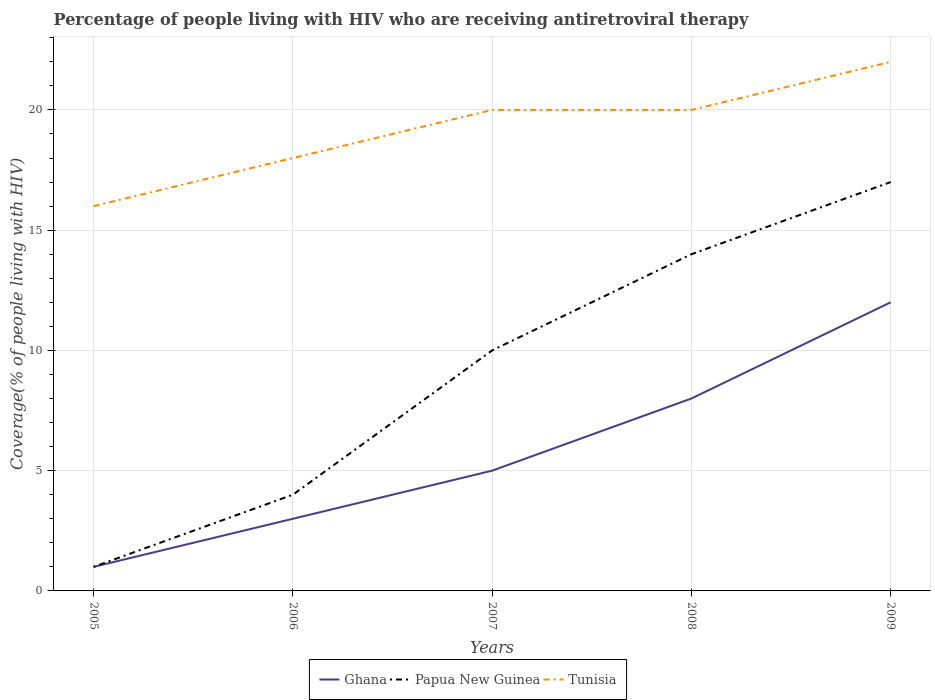How many different coloured lines are there?
Provide a short and direct response. 3. Does the line corresponding to Tunisia intersect with the line corresponding to Ghana?
Ensure brevity in your answer.  No. Is the number of lines equal to the number of legend labels?
Your answer should be compact. Yes. Across all years, what is the maximum percentage of the HIV infected people who are receiving antiretroviral therapy in Ghana?
Offer a terse response. 1. In which year was the percentage of the HIV infected people who are receiving antiretroviral therapy in Tunisia maximum?
Make the answer very short. 2005. What is the total percentage of the HIV infected people who are receiving antiretroviral therapy in Papua New Guinea in the graph?
Your response must be concise. -3. Are the values on the major ticks of Y-axis written in scientific E-notation?
Your answer should be very brief. No. Does the graph contain any zero values?
Give a very brief answer. No. Does the graph contain grids?
Provide a short and direct response. Yes. Where does the legend appear in the graph?
Offer a terse response. Bottom center. How many legend labels are there?
Provide a succinct answer. 3. How are the legend labels stacked?
Provide a succinct answer. Horizontal. What is the title of the graph?
Provide a short and direct response. Percentage of people living with HIV who are receiving antiretroviral therapy. What is the label or title of the X-axis?
Offer a very short reply. Years. What is the label or title of the Y-axis?
Offer a terse response. Coverage(% of people living with HIV). What is the Coverage(% of people living with HIV) of Papua New Guinea in 2006?
Give a very brief answer. 4. What is the Coverage(% of people living with HIV) in Papua New Guinea in 2008?
Your answer should be very brief. 14. What is the Coverage(% of people living with HIV) of Ghana in 2009?
Offer a terse response. 12. What is the Coverage(% of people living with HIV) of Tunisia in 2009?
Keep it short and to the point. 22. Across all years, what is the maximum Coverage(% of people living with HIV) in Ghana?
Keep it short and to the point. 12. Across all years, what is the maximum Coverage(% of people living with HIV) of Tunisia?
Keep it short and to the point. 22. Across all years, what is the minimum Coverage(% of people living with HIV) in Ghana?
Give a very brief answer. 1. What is the total Coverage(% of people living with HIV) of Tunisia in the graph?
Offer a very short reply. 96. What is the difference between the Coverage(% of people living with HIV) in Papua New Guinea in 2005 and that in 2006?
Provide a succinct answer. -3. What is the difference between the Coverage(% of people living with HIV) in Ghana in 2005 and that in 2007?
Make the answer very short. -4. What is the difference between the Coverage(% of people living with HIV) of Papua New Guinea in 2005 and that in 2007?
Keep it short and to the point. -9. What is the difference between the Coverage(% of people living with HIV) in Tunisia in 2005 and that in 2007?
Ensure brevity in your answer.  -4. What is the difference between the Coverage(% of people living with HIV) in Papua New Guinea in 2005 and that in 2009?
Keep it short and to the point. -16. What is the difference between the Coverage(% of people living with HIV) of Tunisia in 2005 and that in 2009?
Provide a succinct answer. -6. What is the difference between the Coverage(% of people living with HIV) in Ghana in 2006 and that in 2007?
Provide a short and direct response. -2. What is the difference between the Coverage(% of people living with HIV) of Papua New Guinea in 2006 and that in 2007?
Your response must be concise. -6. What is the difference between the Coverage(% of people living with HIV) in Tunisia in 2006 and that in 2009?
Your answer should be very brief. -4. What is the difference between the Coverage(% of people living with HIV) of Tunisia in 2007 and that in 2008?
Offer a terse response. 0. What is the difference between the Coverage(% of people living with HIV) of Papua New Guinea in 2007 and that in 2009?
Offer a terse response. -7. What is the difference between the Coverage(% of people living with HIV) in Ghana in 2008 and that in 2009?
Your response must be concise. -4. What is the difference between the Coverage(% of people living with HIV) of Ghana in 2005 and the Coverage(% of people living with HIV) of Papua New Guinea in 2006?
Your answer should be compact. -3. What is the difference between the Coverage(% of people living with HIV) of Ghana in 2005 and the Coverage(% of people living with HIV) of Tunisia in 2006?
Ensure brevity in your answer.  -17. What is the difference between the Coverage(% of people living with HIV) in Ghana in 2005 and the Coverage(% of people living with HIV) in Papua New Guinea in 2007?
Your response must be concise. -9. What is the difference between the Coverage(% of people living with HIV) in Ghana in 2005 and the Coverage(% of people living with HIV) in Tunisia in 2007?
Give a very brief answer. -19. What is the difference between the Coverage(% of people living with HIV) of Ghana in 2005 and the Coverage(% of people living with HIV) of Papua New Guinea in 2008?
Ensure brevity in your answer.  -13. What is the difference between the Coverage(% of people living with HIV) of Ghana in 2005 and the Coverage(% of people living with HIV) of Tunisia in 2008?
Give a very brief answer. -19. What is the difference between the Coverage(% of people living with HIV) in Papua New Guinea in 2005 and the Coverage(% of people living with HIV) in Tunisia in 2008?
Ensure brevity in your answer.  -19. What is the difference between the Coverage(% of people living with HIV) in Ghana in 2006 and the Coverage(% of people living with HIV) in Papua New Guinea in 2007?
Your response must be concise. -7. What is the difference between the Coverage(% of people living with HIV) in Papua New Guinea in 2006 and the Coverage(% of people living with HIV) in Tunisia in 2007?
Make the answer very short. -16. What is the difference between the Coverage(% of people living with HIV) in Papua New Guinea in 2006 and the Coverage(% of people living with HIV) in Tunisia in 2008?
Give a very brief answer. -16. What is the difference between the Coverage(% of people living with HIV) in Ghana in 2006 and the Coverage(% of people living with HIV) in Tunisia in 2009?
Provide a succinct answer. -19. What is the difference between the Coverage(% of people living with HIV) in Ghana in 2007 and the Coverage(% of people living with HIV) in Papua New Guinea in 2008?
Keep it short and to the point. -9. What is the difference between the Coverage(% of people living with HIV) of Papua New Guinea in 2007 and the Coverage(% of people living with HIV) of Tunisia in 2008?
Provide a succinct answer. -10. What is the difference between the Coverage(% of people living with HIV) in Ghana in 2007 and the Coverage(% of people living with HIV) in Papua New Guinea in 2009?
Offer a very short reply. -12. What is the difference between the Coverage(% of people living with HIV) in Ghana in 2008 and the Coverage(% of people living with HIV) in Papua New Guinea in 2009?
Provide a succinct answer. -9. What is the average Coverage(% of people living with HIV) of Ghana per year?
Ensure brevity in your answer.  5.8. In the year 2005, what is the difference between the Coverage(% of people living with HIV) in Ghana and Coverage(% of people living with HIV) in Papua New Guinea?
Offer a terse response. 0. In the year 2005, what is the difference between the Coverage(% of people living with HIV) of Papua New Guinea and Coverage(% of people living with HIV) of Tunisia?
Ensure brevity in your answer.  -15. In the year 2006, what is the difference between the Coverage(% of people living with HIV) of Ghana and Coverage(% of people living with HIV) of Tunisia?
Offer a terse response. -15. In the year 2006, what is the difference between the Coverage(% of people living with HIV) of Papua New Guinea and Coverage(% of people living with HIV) of Tunisia?
Your response must be concise. -14. In the year 2007, what is the difference between the Coverage(% of people living with HIV) of Papua New Guinea and Coverage(% of people living with HIV) of Tunisia?
Provide a succinct answer. -10. In the year 2008, what is the difference between the Coverage(% of people living with HIV) of Ghana and Coverage(% of people living with HIV) of Papua New Guinea?
Make the answer very short. -6. In the year 2008, what is the difference between the Coverage(% of people living with HIV) in Ghana and Coverage(% of people living with HIV) in Tunisia?
Your answer should be compact. -12. In the year 2008, what is the difference between the Coverage(% of people living with HIV) in Papua New Guinea and Coverage(% of people living with HIV) in Tunisia?
Provide a succinct answer. -6. In the year 2009, what is the difference between the Coverage(% of people living with HIV) of Ghana and Coverage(% of people living with HIV) of Tunisia?
Keep it short and to the point. -10. What is the ratio of the Coverage(% of people living with HIV) in Papua New Guinea in 2005 to that in 2006?
Make the answer very short. 0.25. What is the ratio of the Coverage(% of people living with HIV) of Tunisia in 2005 to that in 2006?
Provide a succinct answer. 0.89. What is the ratio of the Coverage(% of people living with HIV) in Papua New Guinea in 2005 to that in 2007?
Ensure brevity in your answer.  0.1. What is the ratio of the Coverage(% of people living with HIV) of Tunisia in 2005 to that in 2007?
Your response must be concise. 0.8. What is the ratio of the Coverage(% of people living with HIV) of Ghana in 2005 to that in 2008?
Your response must be concise. 0.12. What is the ratio of the Coverage(% of people living with HIV) in Papua New Guinea in 2005 to that in 2008?
Offer a terse response. 0.07. What is the ratio of the Coverage(% of people living with HIV) in Ghana in 2005 to that in 2009?
Give a very brief answer. 0.08. What is the ratio of the Coverage(% of people living with HIV) of Papua New Guinea in 2005 to that in 2009?
Offer a very short reply. 0.06. What is the ratio of the Coverage(% of people living with HIV) of Tunisia in 2005 to that in 2009?
Ensure brevity in your answer.  0.73. What is the ratio of the Coverage(% of people living with HIV) in Papua New Guinea in 2006 to that in 2008?
Your response must be concise. 0.29. What is the ratio of the Coverage(% of people living with HIV) of Ghana in 2006 to that in 2009?
Ensure brevity in your answer.  0.25. What is the ratio of the Coverage(% of people living with HIV) in Papua New Guinea in 2006 to that in 2009?
Provide a succinct answer. 0.24. What is the ratio of the Coverage(% of people living with HIV) in Tunisia in 2006 to that in 2009?
Make the answer very short. 0.82. What is the ratio of the Coverage(% of people living with HIV) in Tunisia in 2007 to that in 2008?
Your answer should be compact. 1. What is the ratio of the Coverage(% of people living with HIV) in Ghana in 2007 to that in 2009?
Your response must be concise. 0.42. What is the ratio of the Coverage(% of people living with HIV) in Papua New Guinea in 2007 to that in 2009?
Your response must be concise. 0.59. What is the ratio of the Coverage(% of people living with HIV) in Tunisia in 2007 to that in 2009?
Make the answer very short. 0.91. What is the ratio of the Coverage(% of people living with HIV) of Ghana in 2008 to that in 2009?
Give a very brief answer. 0.67. What is the ratio of the Coverage(% of people living with HIV) of Papua New Guinea in 2008 to that in 2009?
Offer a very short reply. 0.82. What is the ratio of the Coverage(% of people living with HIV) of Tunisia in 2008 to that in 2009?
Provide a short and direct response. 0.91. What is the difference between the highest and the second highest Coverage(% of people living with HIV) of Tunisia?
Your response must be concise. 2. What is the difference between the highest and the lowest Coverage(% of people living with HIV) of Tunisia?
Your answer should be very brief. 6. 